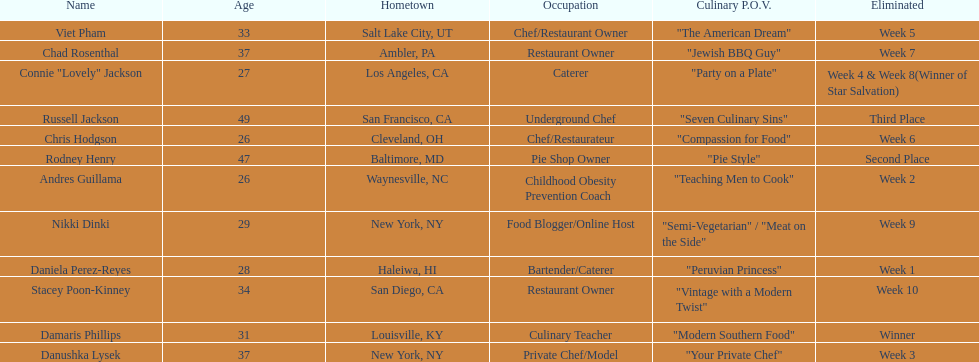Who was the top chef? Damaris Phillips. 